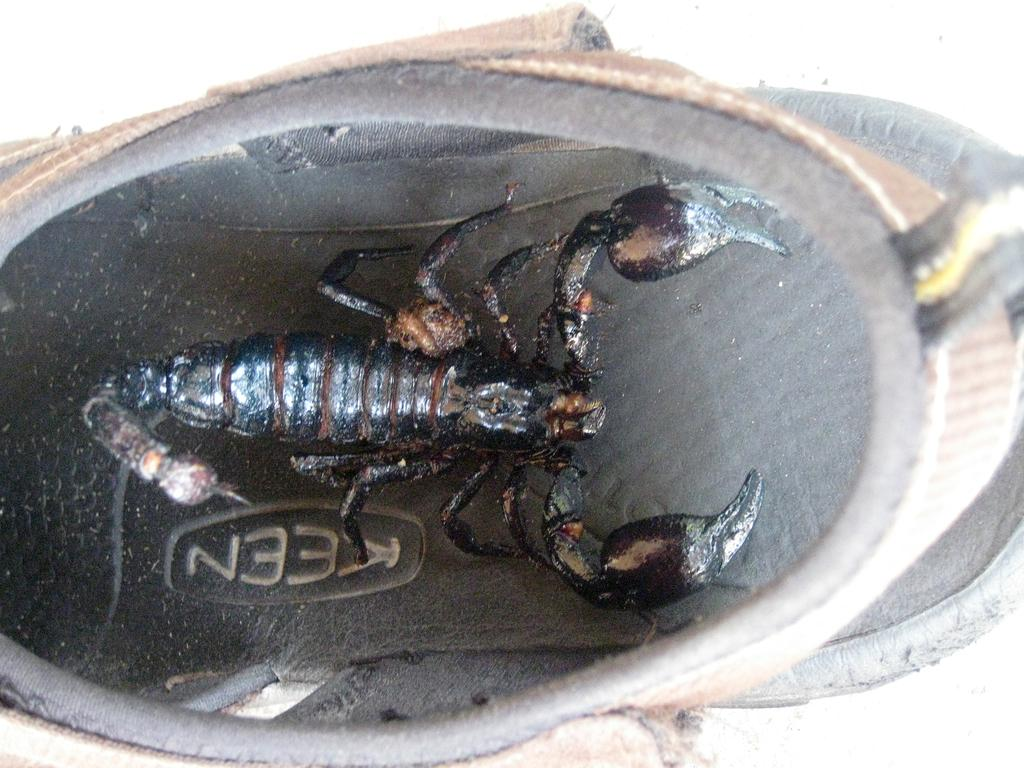<image>
Present a compact description of the photo's key features. Symbol that shows a scorpion and word that says KEEN. 